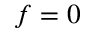<formula> <loc_0><loc_0><loc_500><loc_500>f = 0</formula> 